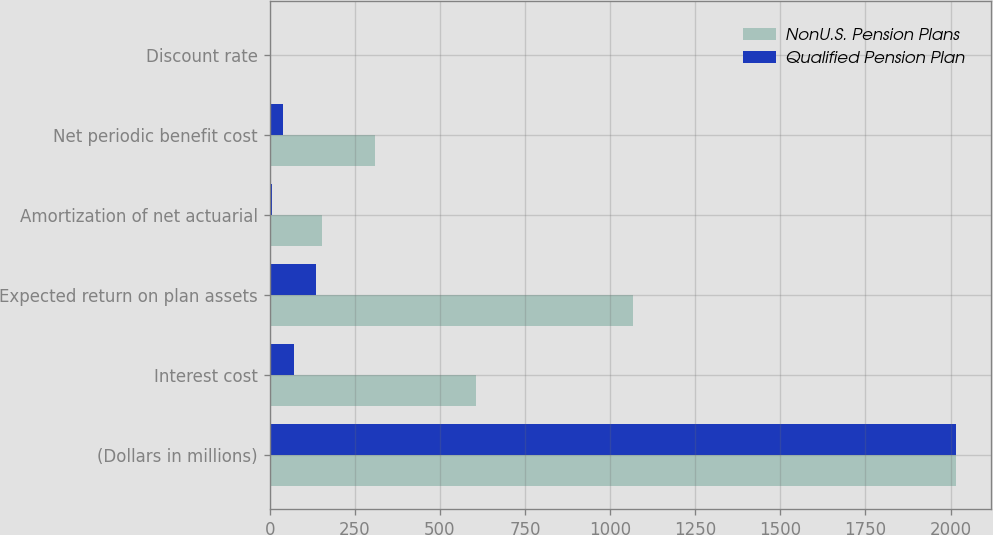<chart> <loc_0><loc_0><loc_500><loc_500><stacked_bar_chart><ecel><fcel>(Dollars in millions)<fcel>Interest cost<fcel>Expected return on plan assets<fcel>Amortization of net actuarial<fcel>Net periodic benefit cost<fcel>Discount rate<nl><fcel>NonU.S. Pension Plans<fcel>2017<fcel>606<fcel>1068<fcel>154<fcel>308<fcel>4.16<nl><fcel>Qualified Pension Plan<fcel>2017<fcel>72<fcel>136<fcel>8<fcel>39<fcel>2.56<nl></chart> 